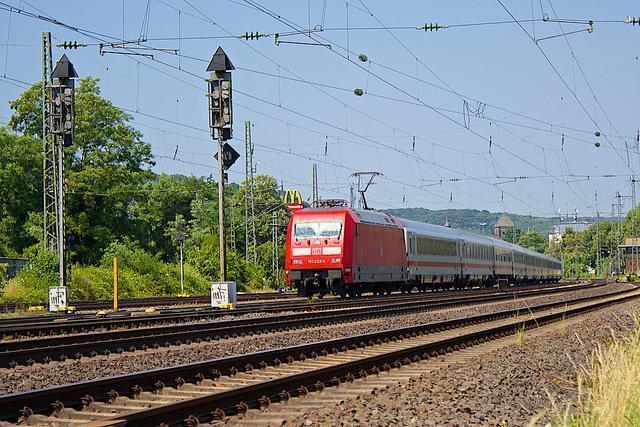How many people are there?
Give a very brief answer. 0. 